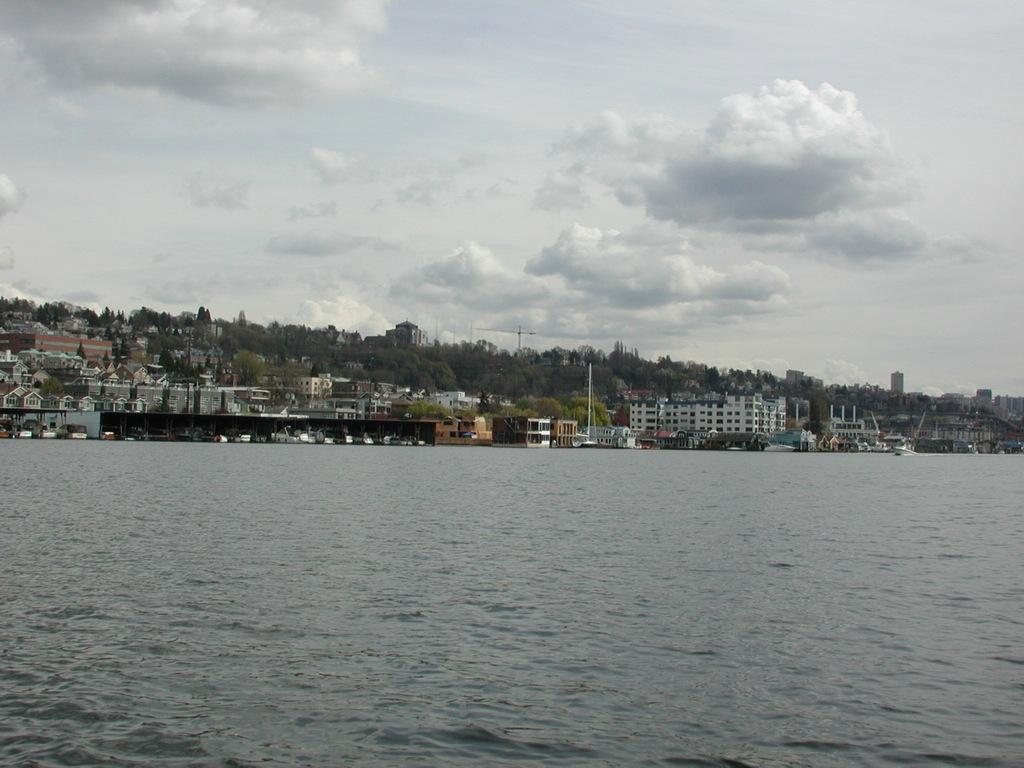What is the primary element in the image? The image contains water. What type of structures can be seen in the image? There are buildings in the image. What else can be seen in the image besides water and buildings? There are poles and trees in the image. What is visible in the background of the image? The sky is visible in the background of the image, and clouds are present in the sky. What type of yam is being used to paint the value of the buildings in the image? There is no yam or painting activity present in the image. The buildings are simply standing structures, and the image does not depict any painting or value assessment. 